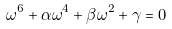<formula> <loc_0><loc_0><loc_500><loc_500>\omega ^ { 6 } + \alpha \omega ^ { 4 } + \beta \omega ^ { 2 } + \gamma = 0</formula> 